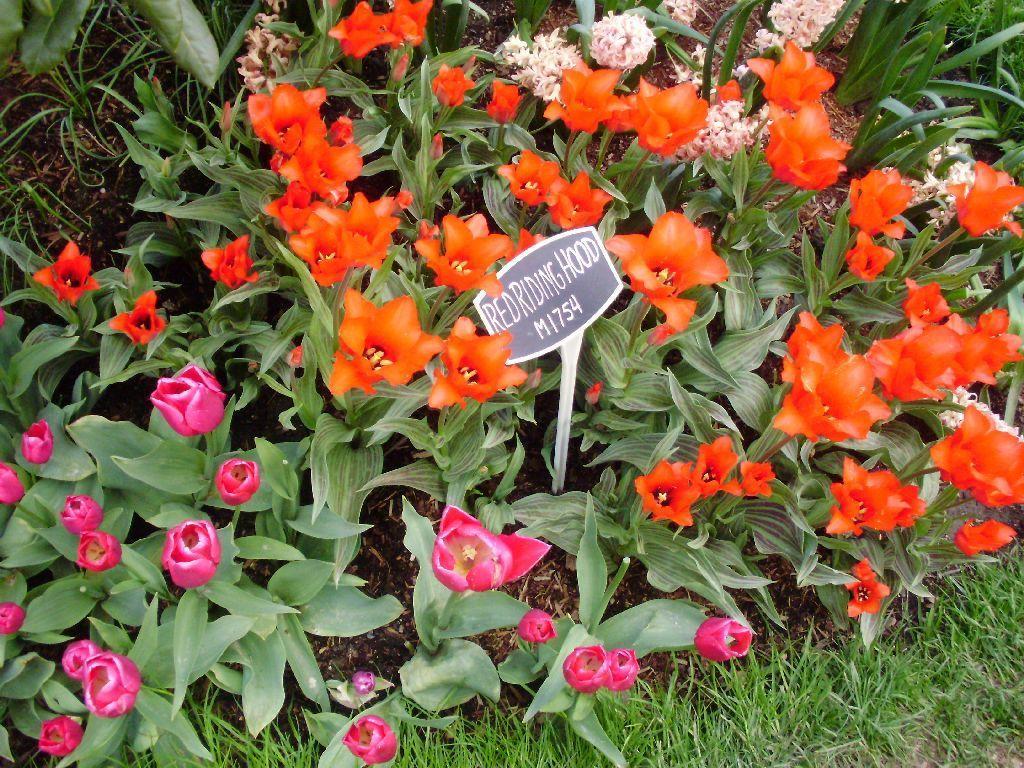In one or two sentences, can you explain what this image depicts? In this image there are some plants flowers and grass, and in the center there is some board. On the board there is text. 